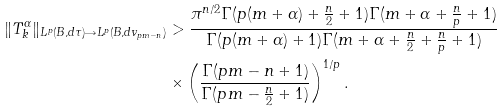<formula> <loc_0><loc_0><loc_500><loc_500>\| T _ { k } ^ { \alpha } \| _ { L ^ { p } ( B , d \tau ) \rightarrow L ^ { p } ( B , d v _ { p m - n } ) } & > \frac { \pi ^ { n / 2 } \Gamma ( p ( m + \alpha ) + \frac { n } { 2 } + 1 ) \Gamma ( m + \alpha + \frac { n } { p } + 1 ) } { \Gamma ( p ( m + \alpha ) + 1 ) \Gamma ( m + \alpha + \frac { n } { 2 } + \frac { n } { p } + 1 ) } \\ & \times \left ( \frac { \Gamma ( p m - n + 1 ) } { \Gamma ( p m - \frac { n } { 2 } + 1 ) } \right ) ^ { 1 / p } .</formula> 